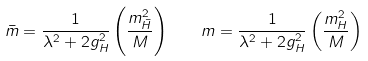<formula> <loc_0><loc_0><loc_500><loc_500>\bar { m } = { \frac { 1 } { \lambda ^ { 2 } + 2 g _ { H } ^ { 2 } } } \left ( \frac { m _ { \bar { H } } ^ { 2 } } { M } \right ) \quad m = { \frac { 1 } { \lambda ^ { 2 } + 2 g _ { H } ^ { 2 } } } \left ( \frac { m _ { H } ^ { 2 } } { M } \right )</formula> 